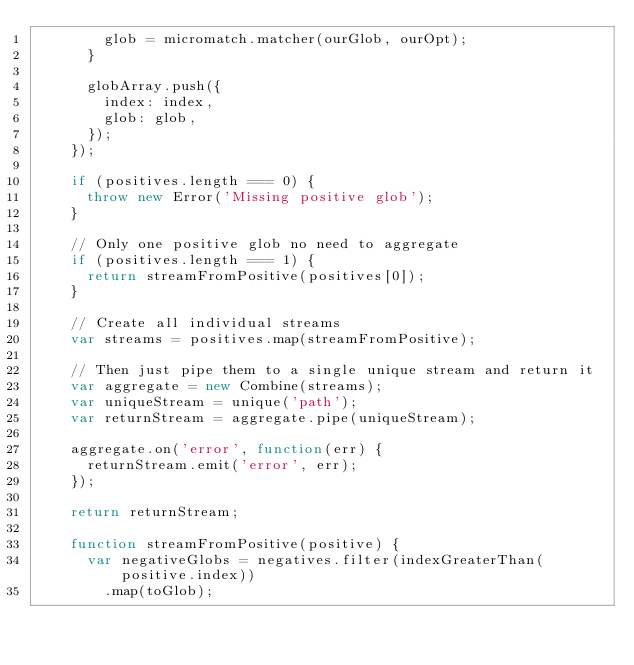Convert code to text. <code><loc_0><loc_0><loc_500><loc_500><_JavaScript_>        glob = micromatch.matcher(ourGlob, ourOpt);
      }

      globArray.push({
        index: index,
        glob: glob,
      });
    });

    if (positives.length === 0) {
      throw new Error('Missing positive glob');
    }

    // Only one positive glob no need to aggregate
    if (positives.length === 1) {
      return streamFromPositive(positives[0]);
    }

    // Create all individual streams
    var streams = positives.map(streamFromPositive);

    // Then just pipe them to a single unique stream and return it
    var aggregate = new Combine(streams);
    var uniqueStream = unique('path');
    var returnStream = aggregate.pipe(uniqueStream);

    aggregate.on('error', function(err) {
      returnStream.emit('error', err);
    });

    return returnStream;

    function streamFromPositive(positive) {
      var negativeGlobs = negatives.filter(indexGreaterThan(positive.index))
        .map(toGlob);</code> 